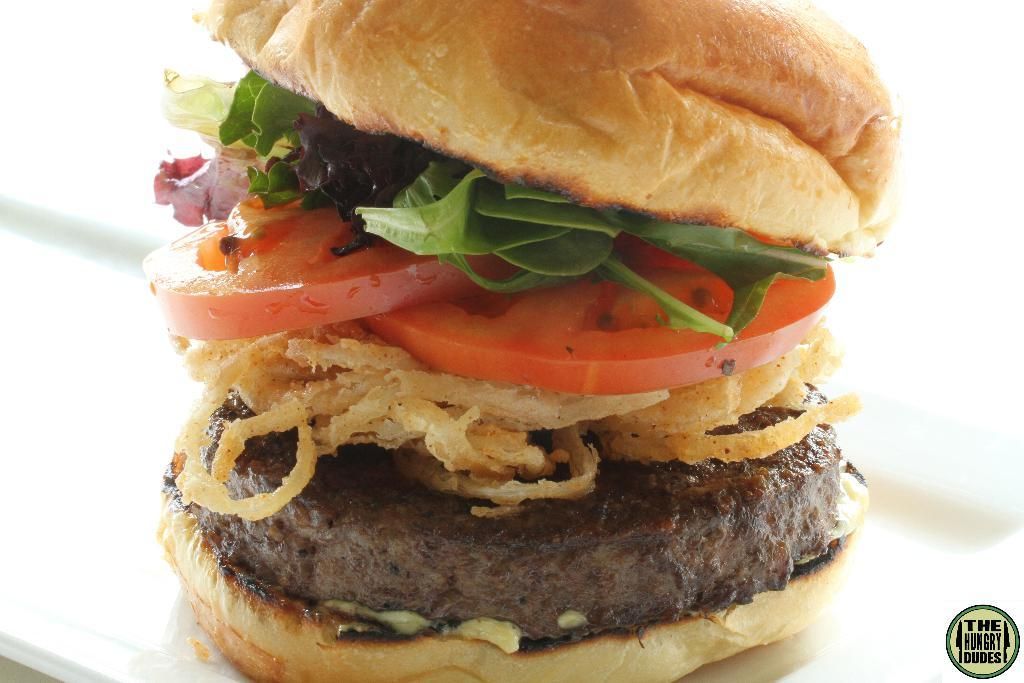What type of food is the main subject of the image? There is a burger in the image. What specific ingredients can be seen in the burger? The burger has tomato slices, onion rings, meat, and other ingredients. What is the color of the background in the image? The background of the image is white. What degree of difficulty is the burger rated in the image? There is no rating or degree of difficulty associated with the burger in the image. Can you see a receipt for the burger in the image? There is no receipt present in the image. 